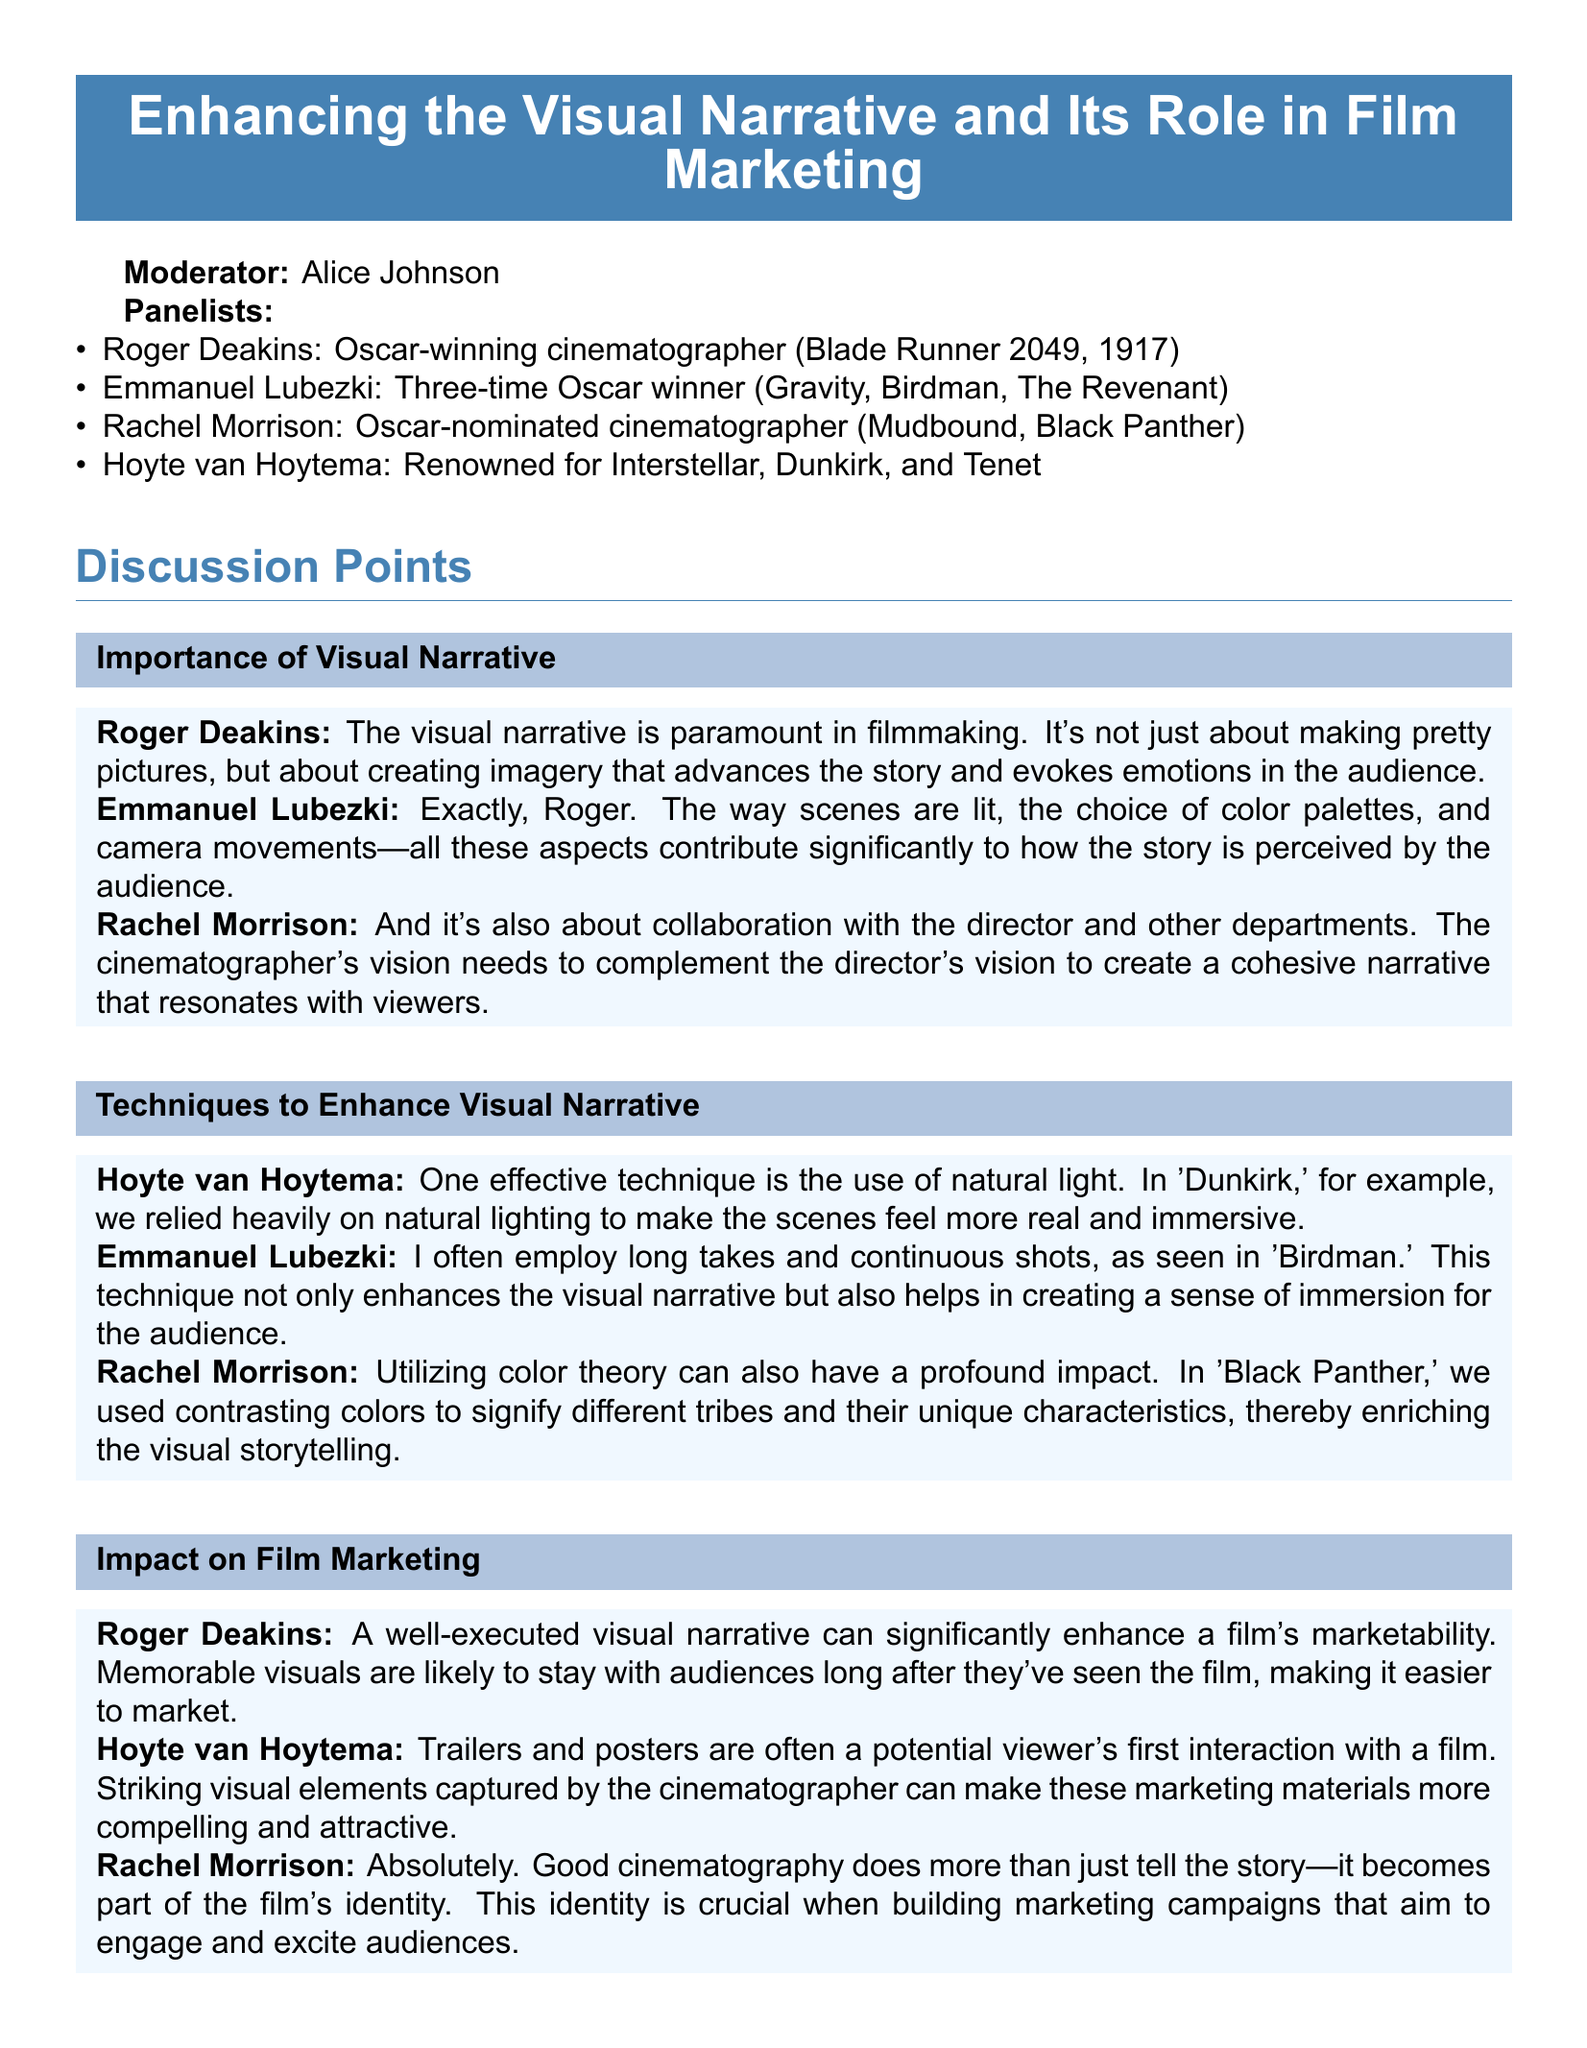What is the title of the panel discussion? The title is clearly stated at the top of the document.
Answer: Enhancing the Visual Narrative and Its Role in Film Marketing Who is the moderator of the discussion? The moderator's name appears before the list of panelists.
Answer: Alice Johnson Which cinematographer won an Oscar for 1917? The document specifies the achievements of Roger Deakins.
Answer: Roger Deakins What lighting technique did Hoyte van Hoytema emphasize in Dunkirk? The document mentions natural lighting specifically in the context of Dunkirk.
Answer: Natural light How many Oscars has Emmanuel Lubezki won? The information is presented in the panelist descriptions section.
Answer: Three-time Oscar winner What visual element does Rachel Morrison associate with different tribes in Black Panther? The document notes the use of color theory in her explanation.
Answer: Contrasting colors Why are striking visual elements important in marketing materials? Hoyte van Hoytema's statement explains their significance in attracting potential viewers.
Answer: Compelling and attractive How do cinematographers influence a film's identity? Rachel Morrison discusses this aspect related to storytelling and marketing.
Answer: Becomes part of the film's identity 